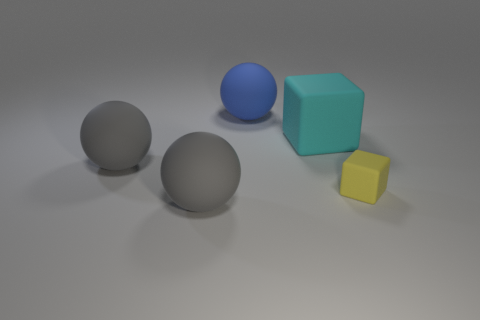Subtract all large blue rubber balls. How many balls are left? 2 Subtract all blue spheres. How many spheres are left? 2 Add 2 tiny cyan rubber cylinders. How many objects exist? 7 Subtract all blue blocks. How many blue spheres are left? 1 Subtract all spheres. How many objects are left? 2 Add 4 small yellow rubber blocks. How many small yellow rubber blocks exist? 5 Subtract 0 purple cubes. How many objects are left? 5 Subtract 2 cubes. How many cubes are left? 0 Subtract all green spheres. Subtract all blue blocks. How many spheres are left? 3 Subtract all big gray rubber balls. Subtract all large gray objects. How many objects are left? 1 